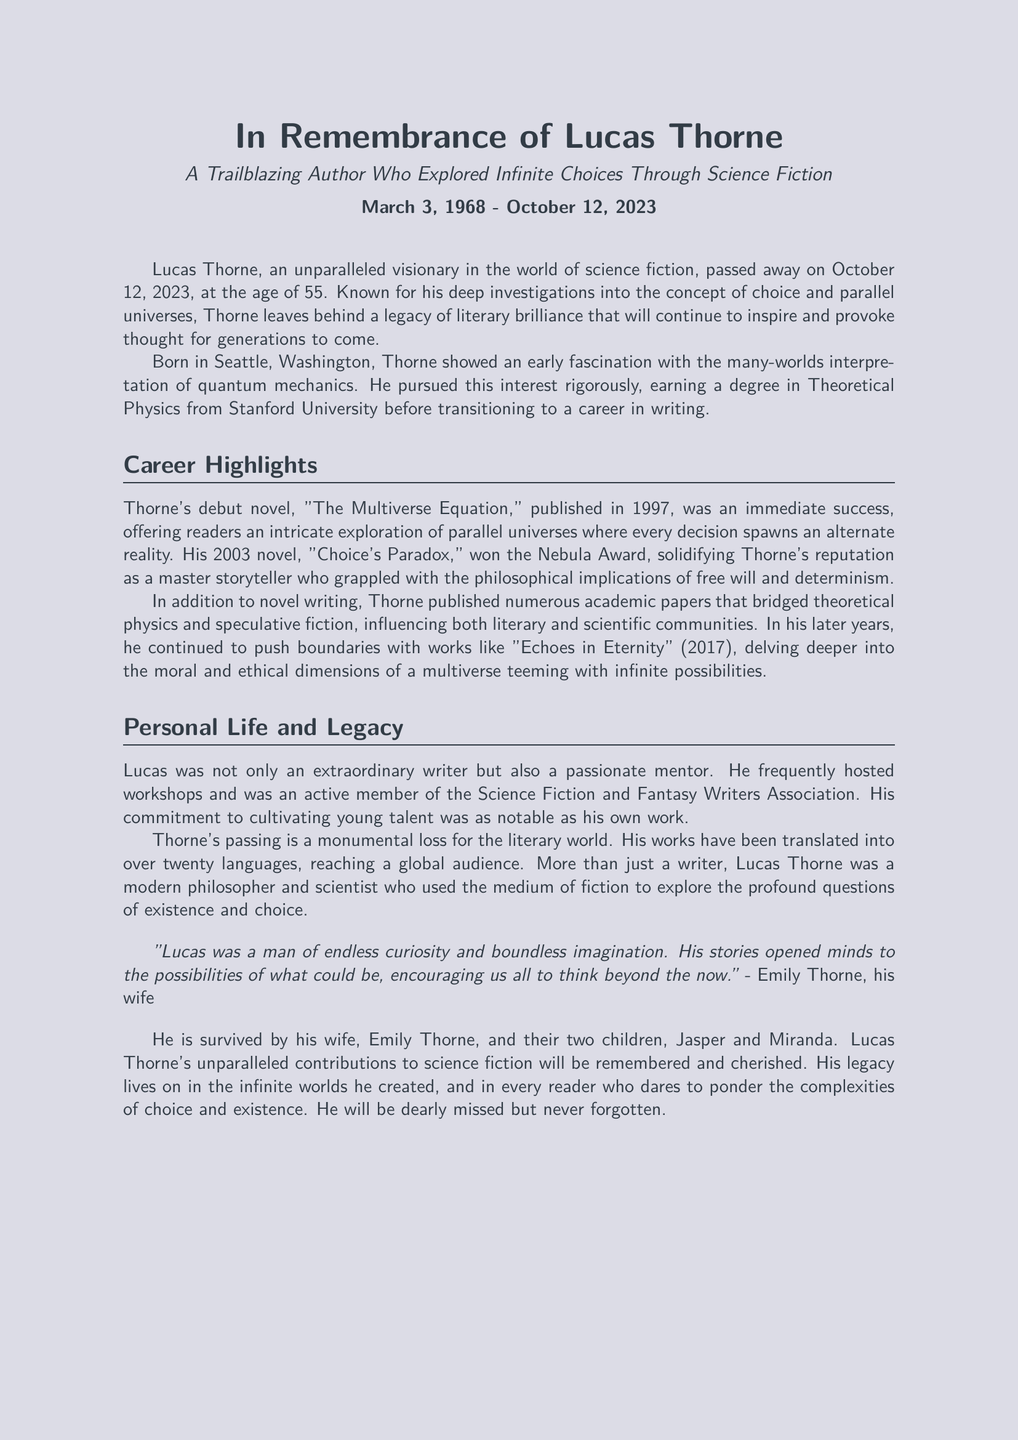What was Lucas Thorne's date of birth? The document states that Lucas Thorne was born on March 3, 1968.
Answer: March 3, 1968 What is the title of Lucas Thorne's debut novel? The document mentions that his debut novel is titled "The Multiverse Equation."
Answer: The Multiverse Equation How old was Lucas Thorne when he passed away? The document indicates that he passed away at the age of 55.
Answer: 55 What award did "Choice's Paradox" win? The document states that "Choice's Paradox" won the Nebula Award.
Answer: Nebula Award Which university did Lucas Thorne attend? The document specifies that he earned a degree in Theoretical Physics from Stanford University.
Answer: Stanford University What was a significant theme in Thorne's works? The document highlights that he explored the concept of choice and parallel universes.
Answer: Choice and parallel universes How many children did Lucas Thorne have? The document mentions that he is survived by two children.
Answer: Two What is the name of Thorne's wife? The document states that his wife's name is Emily Thorne.
Answer: Emily Thorne What kind of community involvement did Thorne have? The document notes that he frequently hosted workshops and was an active member of the Science Fiction and Fantasy Writers Association.
Answer: Active member of the Science Fiction and Fantasy Writers Association 